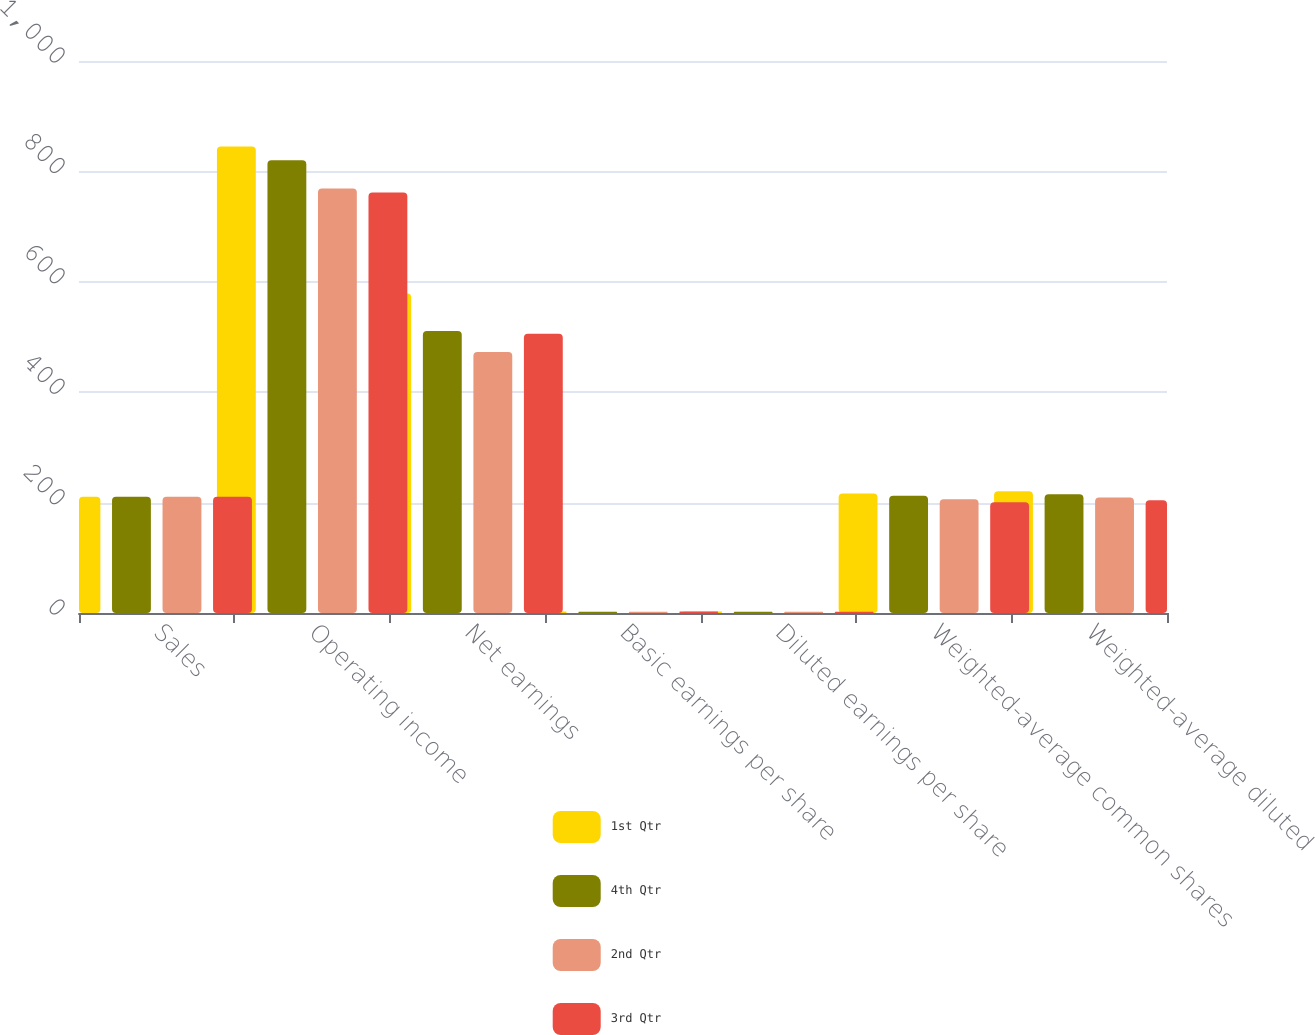Convert chart to OTSL. <chart><loc_0><loc_0><loc_500><loc_500><stacked_bar_chart><ecel><fcel>Sales<fcel>Operating income<fcel>Net earnings<fcel>Basic earnings per share<fcel>Diluted earnings per share<fcel>Weighted-average common shares<fcel>Weighted-average diluted<nl><fcel>1st Qtr<fcel>210.8<fcel>845<fcel>579<fcel>2.68<fcel>2.63<fcel>216.3<fcel>220.4<nl><fcel>4th Qtr<fcel>210.8<fcel>820<fcel>511<fcel>2.41<fcel>2.37<fcel>212.4<fcel>215.2<nl><fcel>2nd Qtr<fcel>210.8<fcel>769<fcel>473<fcel>2.29<fcel>2.26<fcel>206.2<fcel>209.2<nl><fcel>3rd Qtr<fcel>210.8<fcel>762<fcel>506<fcel>2.52<fcel>2.48<fcel>200.8<fcel>204.2<nl></chart> 